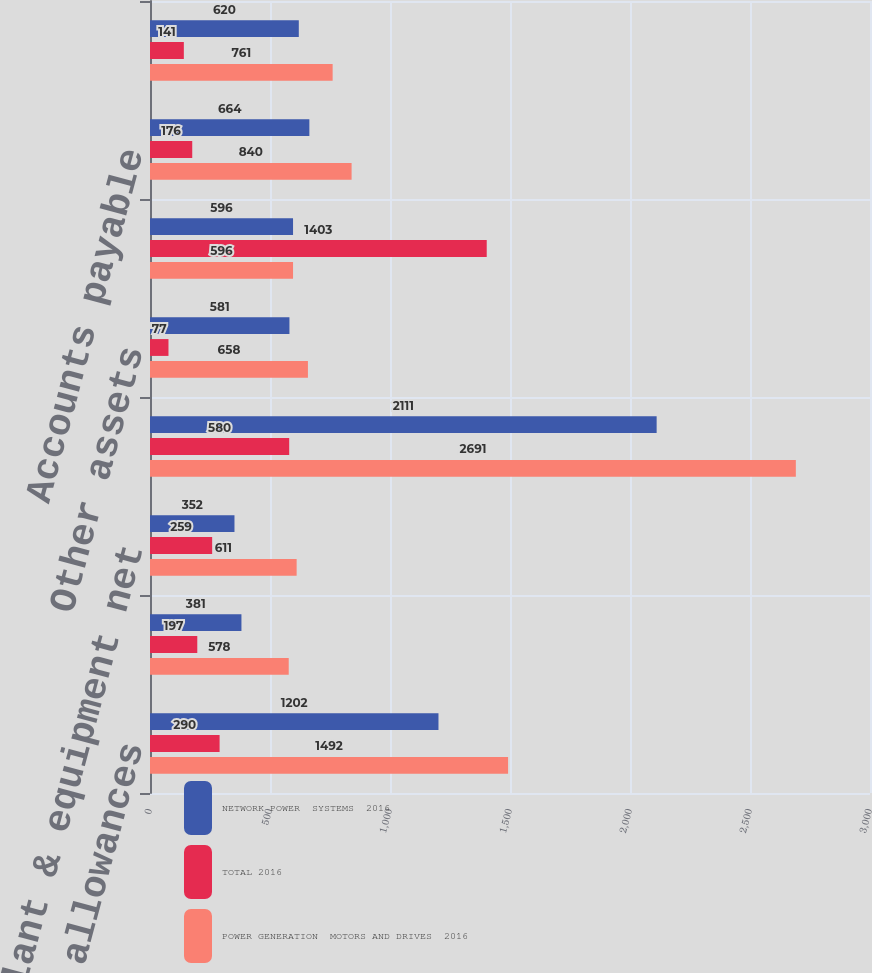Convert chart to OTSL. <chart><loc_0><loc_0><loc_500><loc_500><stacked_bar_chart><ecel><fcel>Receivables less allowances<fcel>Inventories<fcel>Property plant & equipment net<fcel>Goodwill<fcel>Other assets<fcel>Total assets held-for-sale<fcel>Accounts payable<fcel>Other current liabilities<nl><fcel>NETWORK POWER  SYSTEMS  2016<fcel>1202<fcel>381<fcel>352<fcel>2111<fcel>581<fcel>596<fcel>664<fcel>620<nl><fcel>TOTAL 2016<fcel>290<fcel>197<fcel>259<fcel>580<fcel>77<fcel>1403<fcel>176<fcel>141<nl><fcel>POWER GENERATION  MOTORS AND DRIVES  2016<fcel>1492<fcel>578<fcel>611<fcel>2691<fcel>658<fcel>596<fcel>840<fcel>761<nl></chart> 